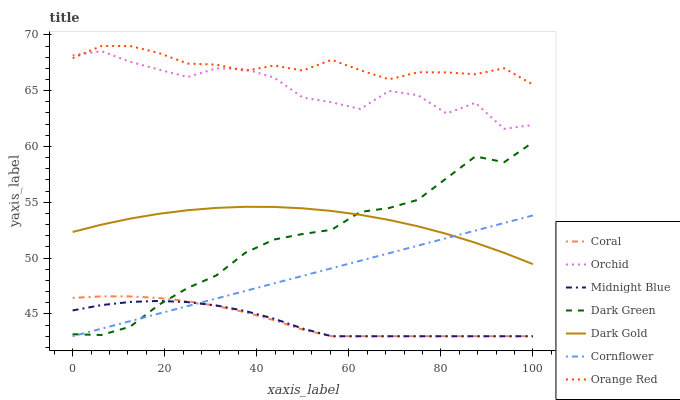Does Midnight Blue have the minimum area under the curve?
Answer yes or no. Yes. Does Orange Red have the maximum area under the curve?
Answer yes or no. Yes. Does Dark Gold have the minimum area under the curve?
Answer yes or no. No. Does Dark Gold have the maximum area under the curve?
Answer yes or no. No. Is Cornflower the smoothest?
Answer yes or no. Yes. Is Orchid the roughest?
Answer yes or no. Yes. Is Midnight Blue the smoothest?
Answer yes or no. No. Is Midnight Blue the roughest?
Answer yes or no. No. Does Cornflower have the lowest value?
Answer yes or no. Yes. Does Dark Gold have the lowest value?
Answer yes or no. No. Does Orange Red have the highest value?
Answer yes or no. Yes. Does Dark Gold have the highest value?
Answer yes or no. No. Is Dark Gold less than Orchid?
Answer yes or no. Yes. Is Orchid greater than Coral?
Answer yes or no. Yes. Does Dark Green intersect Dark Gold?
Answer yes or no. Yes. Is Dark Green less than Dark Gold?
Answer yes or no. No. Is Dark Green greater than Dark Gold?
Answer yes or no. No. Does Dark Gold intersect Orchid?
Answer yes or no. No. 